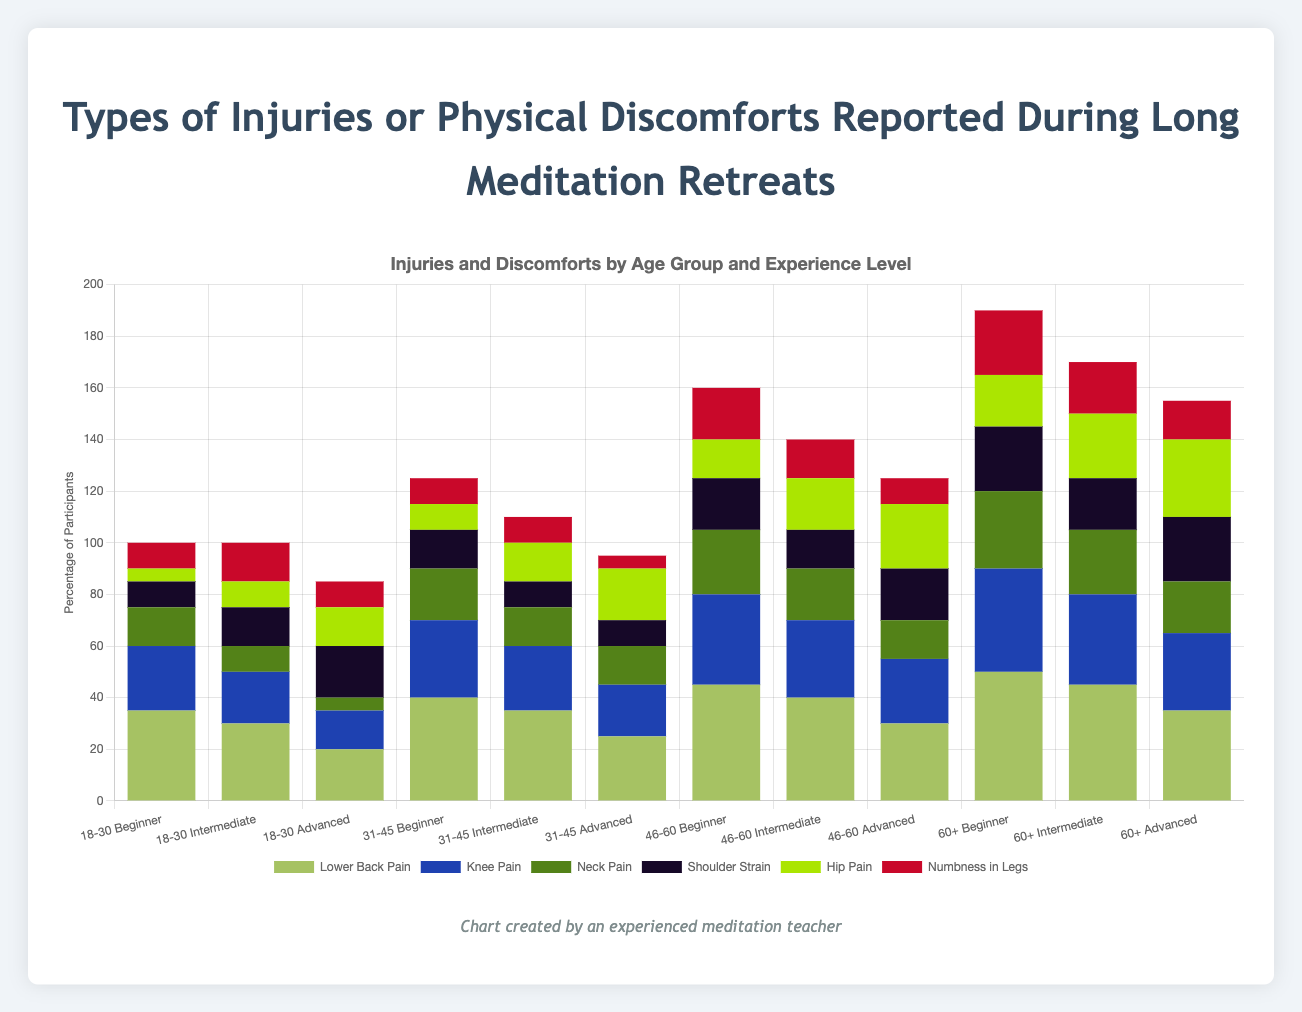What is the most common type of discomfort reported by participants aged 18-30 with beginner-level experience? "Lower Back Pain" has the highest bar among the listed discomforts for beginner participants in the 18-30 age group.
Answer: Lower Back Pain Which age group with advanced experience level reports the least "Numbness in Legs"? Participants in the 31-45 age group with advanced experience level report the least "Numbness in Legs" with a count of 5. By comparing the bars for "Numbness in Legs" for each age group with advanced experience, we see that 31-45 has the smallest bar.
Answer: 31-45 How does the number of participants reporting "Knee Pain" in the 60+ beginner group compare to the same group's reporting of "Shoulder Strain"? For participants aged 60+ with beginner experience, the bar for "Knee Pain" is at 40, and the bar for "Shoulder Strain" is at 25. Hence, 40 is greater than 25.
Answer: Knee Pain is higher What is the combined total of "Hip Pain" and "Neck Pain" reported by participants aged 46-60 with intermediate experience? For the 46-60 age group with intermediate experience, "Hip Pain" is 20 and "Neck Pain" is 20. Combined, 20 + 20 = 40.
Answer: 40 Among all age groups, how is the trend of "Lower Back Pain" reported discomfort as experience level increases? Observing the trends within all age groups, as the experience level increases from beginner to advanced, the reported "Lower Back Pain" consistently decreases. This can be visually verified by the bars for "Lower Back Pain" getting shorter as experience levels progress.
Answer: Decreases Which discomfort is least reported by 31-45 intermediate participants? For the 31-45 age group with intermediate experience, "Numbness in Legs" is the lowest at 10, evident as the shortest bar among all discomforts in this segment.
Answer: Numbness in Legs For the 60+ age group, do advanced experience participants report less "Neck Pain" compared to intermediate experience participants? For the 60+ age group, the bar for "Neck Pain" is lower for advanced experience (20) compared to intermediate experience (25). Hence, 20 is less than 25.
Answer: Yes What is the collective sum of "Shoulder Strain" reported by all advanced experience participants? Adding up "Shoulder Strain" across all age groups for advanced experience: 20 (18-30) + 10 (31-45) + 20 (46-60) + 25 (60+), the total sum is 75.
Answer: 75 Compare the highest reported discomfort in the 46-60 age group across all experience levels. For the 46-60 age group:
- Beginner: "Lower Back Pain" at 45
- Intermediate: "Lower Back Pain" at 40
- Advanced: "Lower Back Pain" at 30. 
So, the highest reported discomfort consistently is "Lower Back Pain."
Answer: Lower Back Pain 